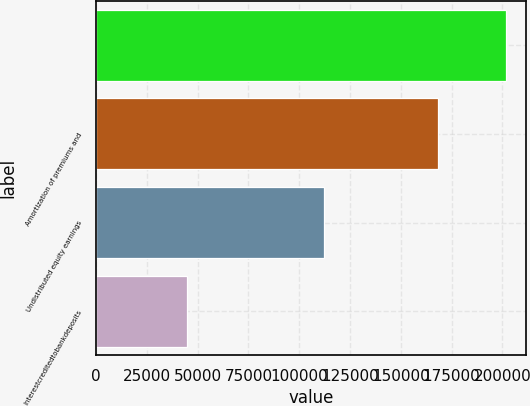Convert chart. <chart><loc_0><loc_0><loc_500><loc_500><bar_chart><ecel><fcel>Amortization of premiums and<fcel>Undistributed equity earnings<fcel>Interestcreditedtobankdeposits<nl><fcel>201671<fcel>168068<fcel>112062<fcel>44855.4<nl></chart> 